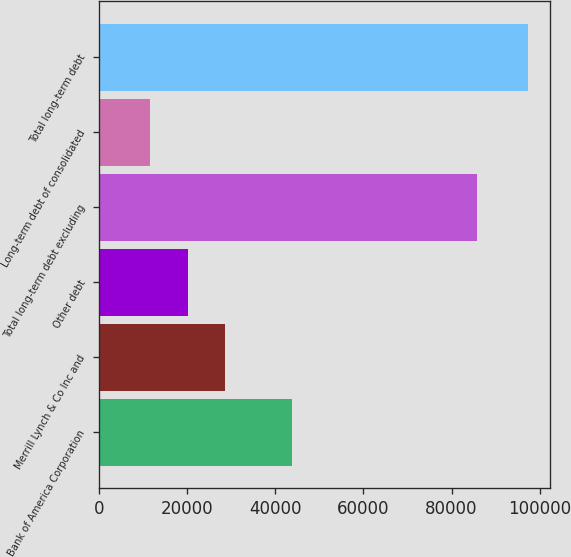Convert chart to OTSL. <chart><loc_0><loc_0><loc_500><loc_500><bar_chart><fcel>Bank of America Corporation<fcel>Merrill Lynch & Co Inc and<fcel>Other debt<fcel>Total long-term debt excluding<fcel>Long-term debt of consolidated<fcel>Total long-term debt<nl><fcel>43877<fcel>28707<fcel>20118.5<fcel>85885<fcel>11530<fcel>97415<nl></chart> 